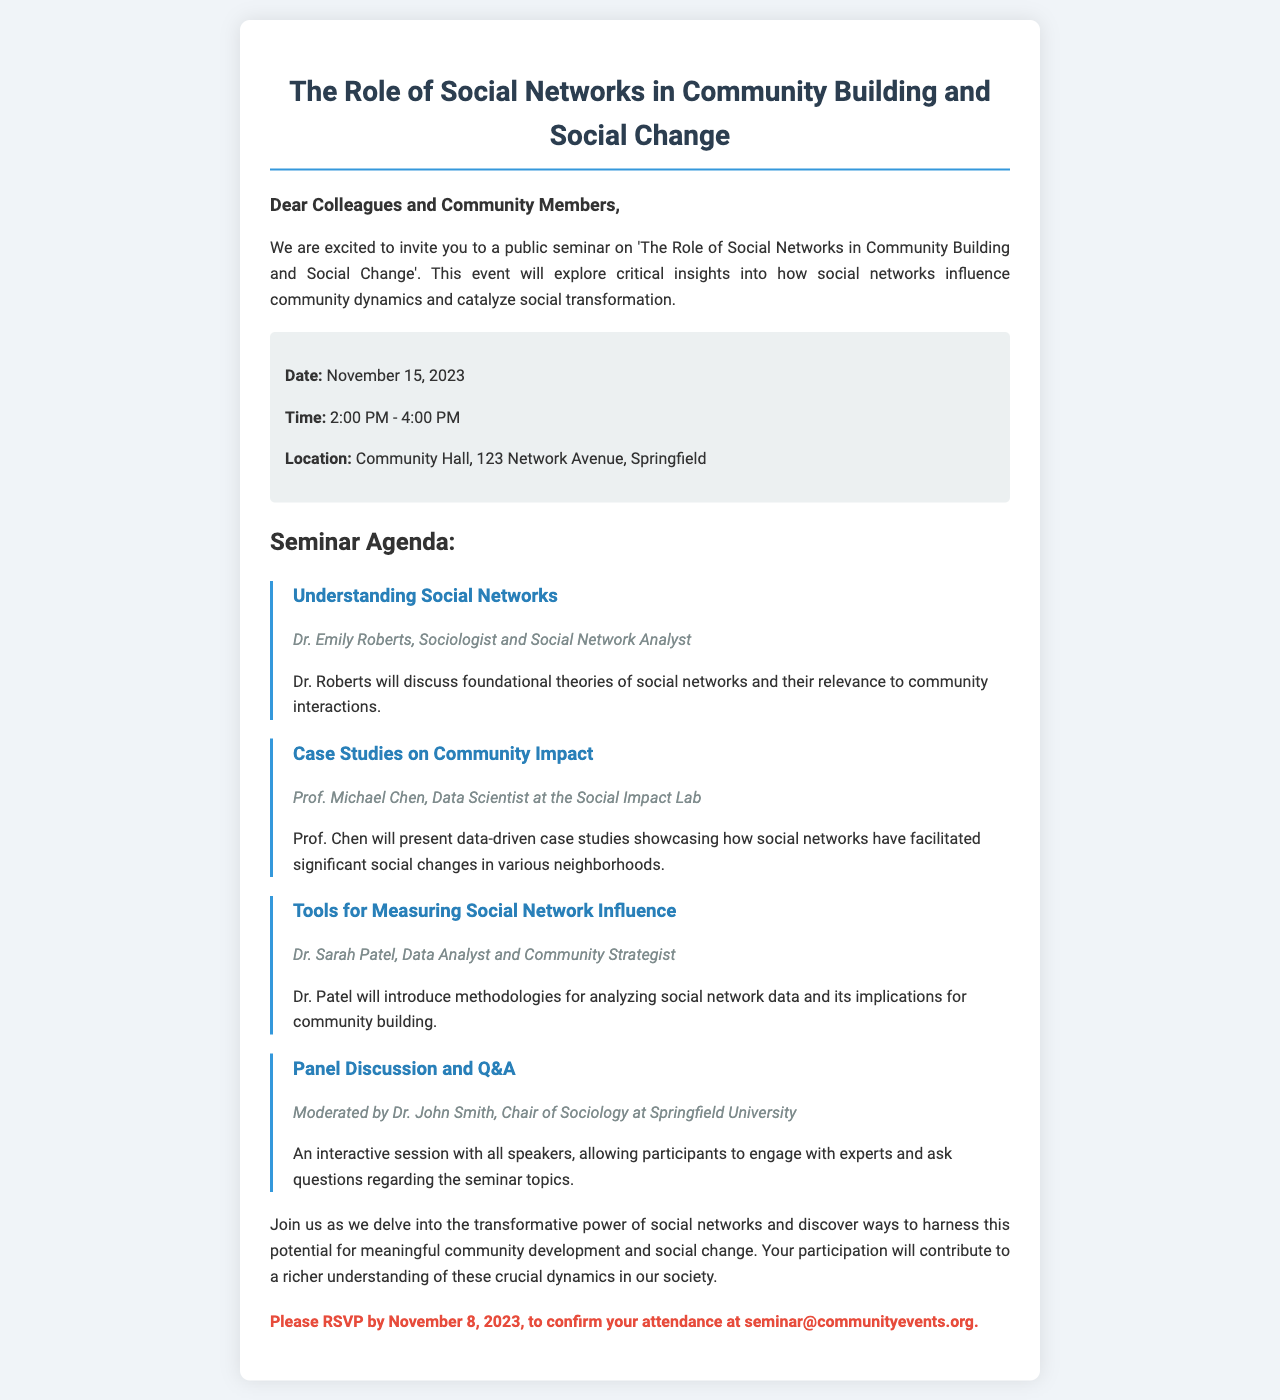What is the date of the seminar? The document specifies that the seminar will be held on November 15, 2023.
Answer: November 15, 2023 What time does the seminar start? The time mentioned in the document for the seminar start is 2:00 PM.
Answer: 2:00 PM Where is the seminar located? The location provided in the document is Community Hall, 123 Network Avenue, Springfield.
Answer: Community Hall, 123 Network Avenue, Springfield Who is the speaker discussing foundational theories of social networks? The document mentions that Dr. Emily Roberts will discuss foundational theories of social networks.
Answer: Dr. Emily Roberts What will Prof. Michael Chen present? According to the document, Prof. Chen will present data-driven case studies showcasing social network impacts.
Answer: Data-driven case studies How many agenda items are listed in the seminar? The document lists four agenda items for the seminar.
Answer: Four What should participants do by November 8, 2023? The document states that participants should RSVP by that date.
Answer: RSVP What is the main theme of the seminar? The theme of the seminar, as indicated in the document, is the role of social networks in community building and social change.
Answer: The role of social networks in community building and social change Who is moderating the panel discussion? The document specifies that the panel discussion is moderated by Dr. John Smith.
Answer: Dr. John Smith 